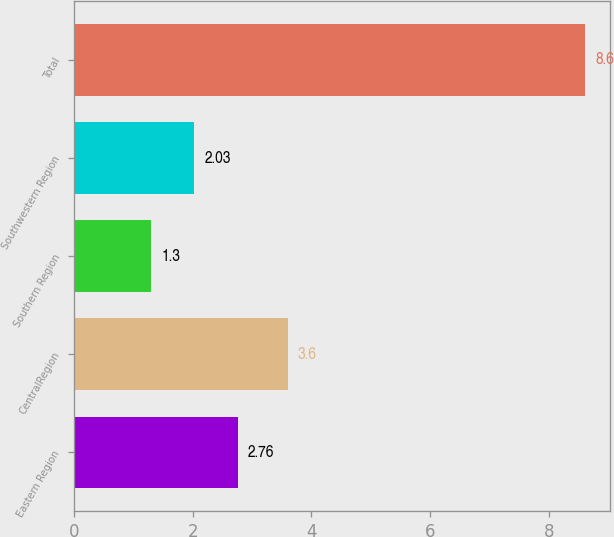<chart> <loc_0><loc_0><loc_500><loc_500><bar_chart><fcel>Eastern Region<fcel>CentralRegion<fcel>Southern Region<fcel>Southwestern Region<fcel>Total<nl><fcel>2.76<fcel>3.6<fcel>1.3<fcel>2.03<fcel>8.6<nl></chart> 